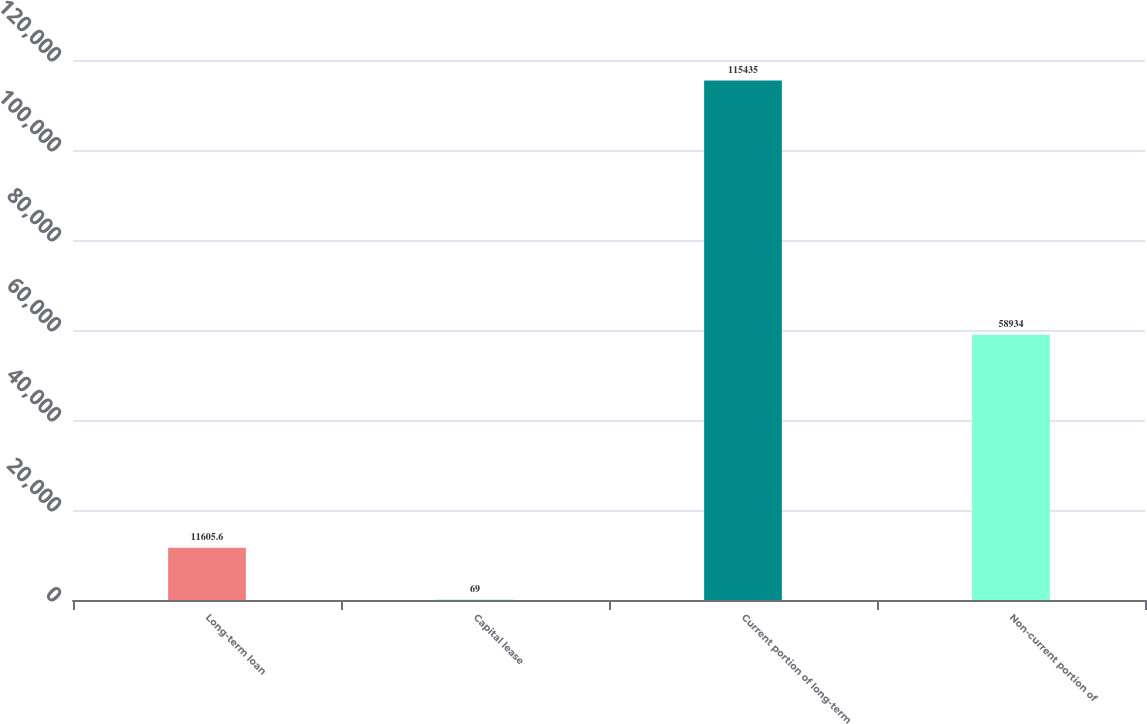<chart> <loc_0><loc_0><loc_500><loc_500><bar_chart><fcel>Long-term loan<fcel>Capital lease<fcel>Current portion of long-term<fcel>Non-current portion of<nl><fcel>11605.6<fcel>69<fcel>115435<fcel>58934<nl></chart> 